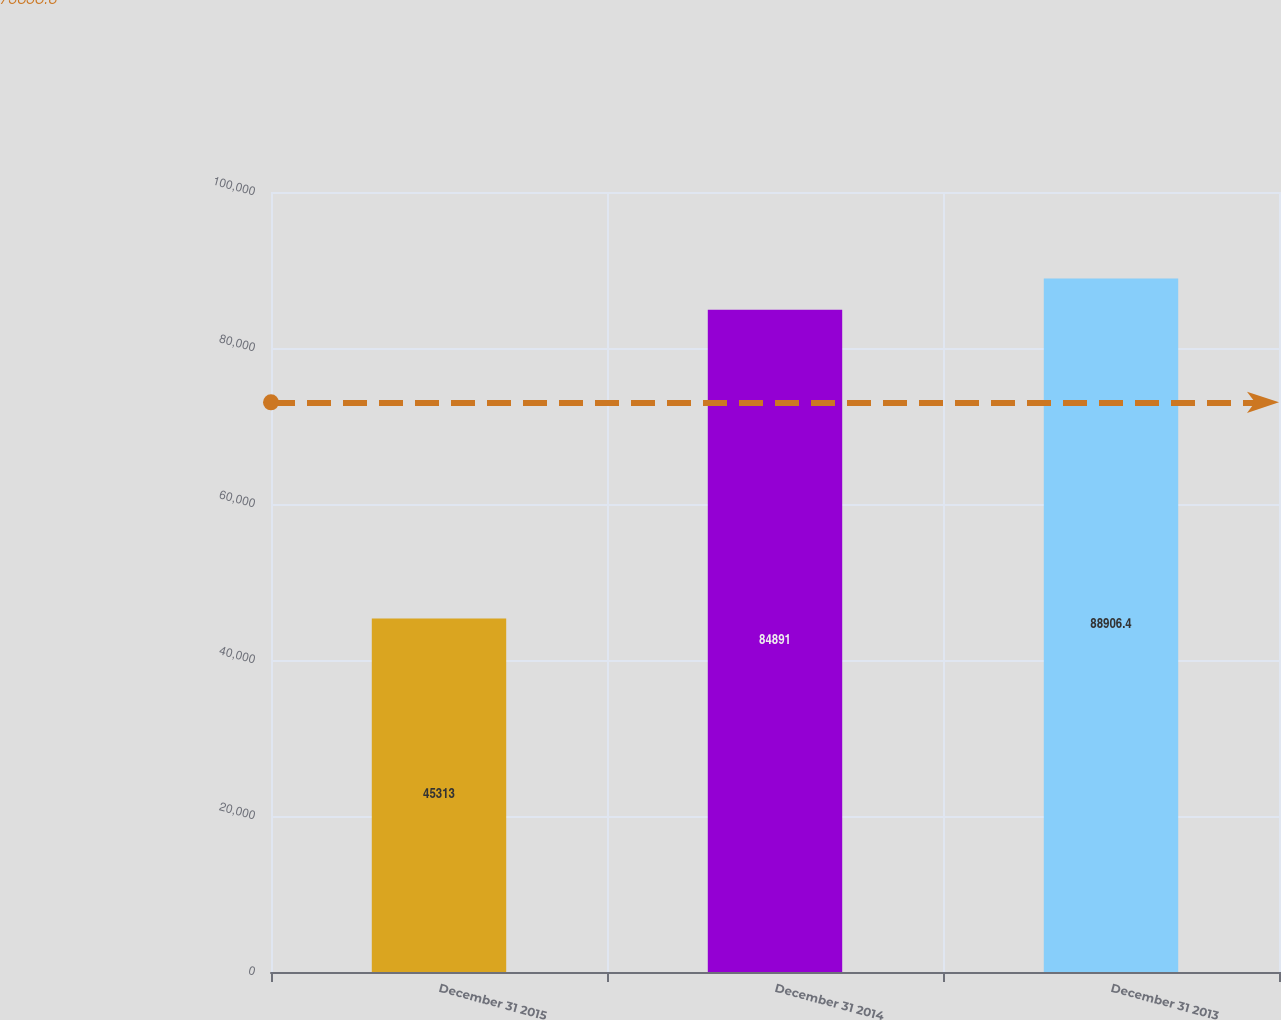Convert chart. <chart><loc_0><loc_0><loc_500><loc_500><bar_chart><fcel>December 31 2015<fcel>December 31 2014<fcel>December 31 2013<nl><fcel>45313<fcel>84891<fcel>88906.4<nl></chart> 